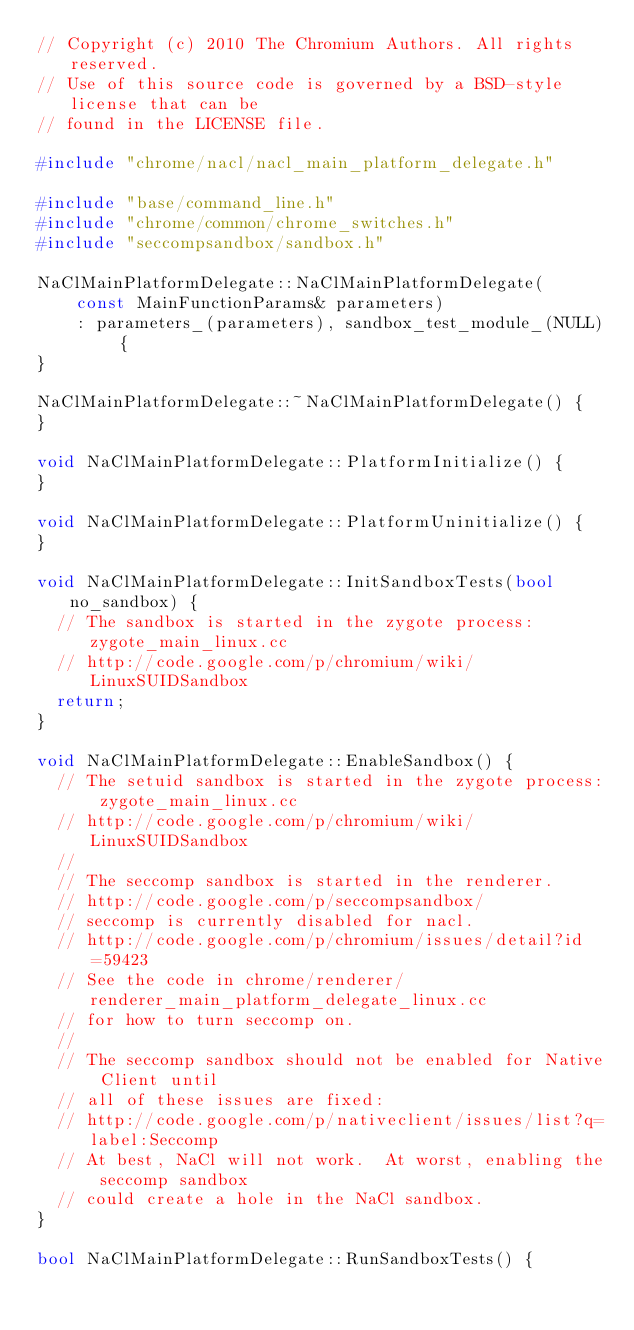Convert code to text. <code><loc_0><loc_0><loc_500><loc_500><_C++_>// Copyright (c) 2010 The Chromium Authors. All rights reserved.
// Use of this source code is governed by a BSD-style license that can be
// found in the LICENSE file.

#include "chrome/nacl/nacl_main_platform_delegate.h"

#include "base/command_line.h"
#include "chrome/common/chrome_switches.h"
#include "seccompsandbox/sandbox.h"

NaClMainPlatformDelegate::NaClMainPlatformDelegate(
    const MainFunctionParams& parameters)
    : parameters_(parameters), sandbox_test_module_(NULL) {
}

NaClMainPlatformDelegate::~NaClMainPlatformDelegate() {
}

void NaClMainPlatformDelegate::PlatformInitialize() {
}

void NaClMainPlatformDelegate::PlatformUninitialize() {
}

void NaClMainPlatformDelegate::InitSandboxTests(bool no_sandbox) {
  // The sandbox is started in the zygote process: zygote_main_linux.cc
  // http://code.google.com/p/chromium/wiki/LinuxSUIDSandbox
  return;
}

void NaClMainPlatformDelegate::EnableSandbox() {
  // The setuid sandbox is started in the zygote process: zygote_main_linux.cc
  // http://code.google.com/p/chromium/wiki/LinuxSUIDSandbox
  //
  // The seccomp sandbox is started in the renderer.
  // http://code.google.com/p/seccompsandbox/
  // seccomp is currently disabled for nacl.
  // http://code.google.com/p/chromium/issues/detail?id=59423
  // See the code in chrome/renderer/renderer_main_platform_delegate_linux.cc
  // for how to turn seccomp on.
  //
  // The seccomp sandbox should not be enabled for Native Client until
  // all of these issues are fixed:
  // http://code.google.com/p/nativeclient/issues/list?q=label:Seccomp
  // At best, NaCl will not work.  At worst, enabling the seccomp sandbox
  // could create a hole in the NaCl sandbox.
}

bool NaClMainPlatformDelegate::RunSandboxTests() {</code> 